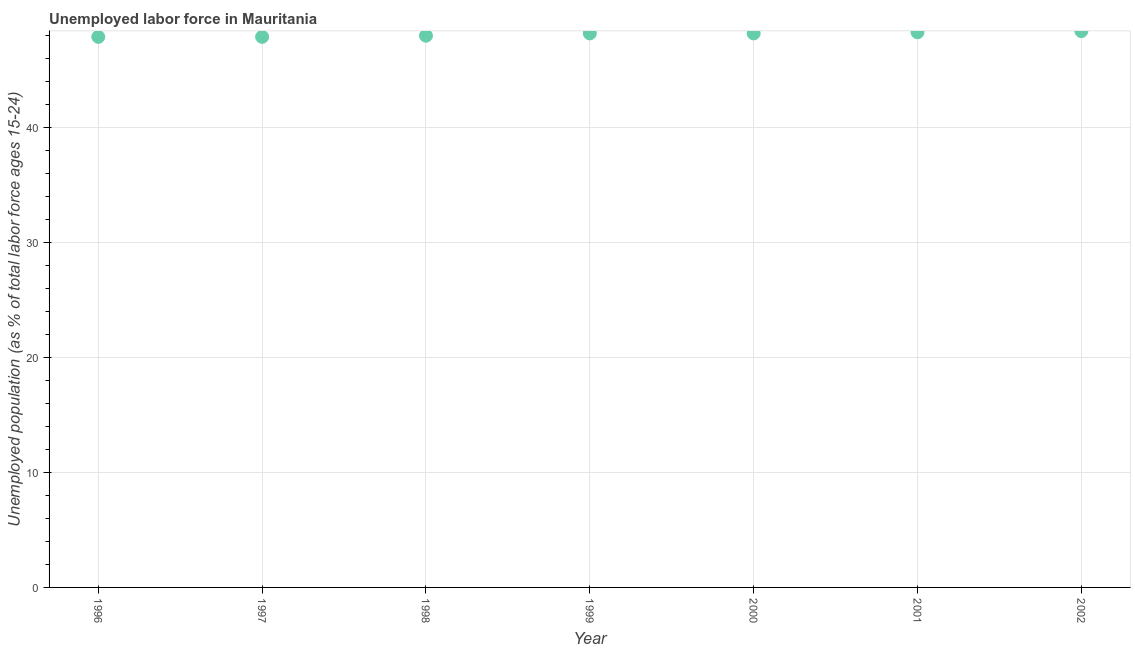Across all years, what is the maximum total unemployed youth population?
Provide a succinct answer. 48.4. Across all years, what is the minimum total unemployed youth population?
Provide a short and direct response. 47.9. What is the sum of the total unemployed youth population?
Offer a very short reply. 336.9. What is the difference between the total unemployed youth population in 1997 and 2002?
Your response must be concise. -0.5. What is the average total unemployed youth population per year?
Give a very brief answer. 48.13. What is the median total unemployed youth population?
Give a very brief answer. 48.2. What is the ratio of the total unemployed youth population in 2000 to that in 2002?
Keep it short and to the point. 1. Is the total unemployed youth population in 1996 less than that in 1997?
Offer a terse response. No. Is the difference between the total unemployed youth population in 1996 and 1998 greater than the difference between any two years?
Offer a very short reply. No. What is the difference between the highest and the second highest total unemployed youth population?
Ensure brevity in your answer.  0.1. Does the total unemployed youth population monotonically increase over the years?
Give a very brief answer. No. Are the values on the major ticks of Y-axis written in scientific E-notation?
Your answer should be compact. No. Does the graph contain any zero values?
Give a very brief answer. No. What is the title of the graph?
Your answer should be compact. Unemployed labor force in Mauritania. What is the label or title of the Y-axis?
Keep it short and to the point. Unemployed population (as % of total labor force ages 15-24). What is the Unemployed population (as % of total labor force ages 15-24) in 1996?
Provide a short and direct response. 47.9. What is the Unemployed population (as % of total labor force ages 15-24) in 1997?
Ensure brevity in your answer.  47.9. What is the Unemployed population (as % of total labor force ages 15-24) in 1999?
Offer a terse response. 48.2. What is the Unemployed population (as % of total labor force ages 15-24) in 2000?
Your response must be concise. 48.2. What is the Unemployed population (as % of total labor force ages 15-24) in 2001?
Your answer should be compact. 48.3. What is the Unemployed population (as % of total labor force ages 15-24) in 2002?
Give a very brief answer. 48.4. What is the difference between the Unemployed population (as % of total labor force ages 15-24) in 1996 and 1997?
Give a very brief answer. 0. What is the difference between the Unemployed population (as % of total labor force ages 15-24) in 1996 and 2000?
Provide a short and direct response. -0.3. What is the difference between the Unemployed population (as % of total labor force ages 15-24) in 1996 and 2002?
Your answer should be very brief. -0.5. What is the difference between the Unemployed population (as % of total labor force ages 15-24) in 1997 and 1999?
Keep it short and to the point. -0.3. What is the difference between the Unemployed population (as % of total labor force ages 15-24) in 1997 and 2001?
Your answer should be compact. -0.4. What is the difference between the Unemployed population (as % of total labor force ages 15-24) in 1997 and 2002?
Give a very brief answer. -0.5. What is the difference between the Unemployed population (as % of total labor force ages 15-24) in 1998 and 1999?
Your answer should be compact. -0.2. What is the difference between the Unemployed population (as % of total labor force ages 15-24) in 1998 and 2001?
Your answer should be very brief. -0.3. What is the difference between the Unemployed population (as % of total labor force ages 15-24) in 1999 and 2000?
Your answer should be compact. 0. What is the difference between the Unemployed population (as % of total labor force ages 15-24) in 1999 and 2002?
Offer a terse response. -0.2. What is the difference between the Unemployed population (as % of total labor force ages 15-24) in 2000 and 2001?
Your answer should be compact. -0.1. What is the difference between the Unemployed population (as % of total labor force ages 15-24) in 2000 and 2002?
Offer a terse response. -0.2. What is the difference between the Unemployed population (as % of total labor force ages 15-24) in 2001 and 2002?
Keep it short and to the point. -0.1. What is the ratio of the Unemployed population (as % of total labor force ages 15-24) in 1996 to that in 1998?
Offer a terse response. 1. What is the ratio of the Unemployed population (as % of total labor force ages 15-24) in 1996 to that in 2002?
Your response must be concise. 0.99. What is the ratio of the Unemployed population (as % of total labor force ages 15-24) in 1997 to that in 1998?
Make the answer very short. 1. What is the ratio of the Unemployed population (as % of total labor force ages 15-24) in 1997 to that in 1999?
Your answer should be compact. 0.99. What is the ratio of the Unemployed population (as % of total labor force ages 15-24) in 1997 to that in 2000?
Offer a terse response. 0.99. What is the ratio of the Unemployed population (as % of total labor force ages 15-24) in 1997 to that in 2001?
Ensure brevity in your answer.  0.99. What is the ratio of the Unemployed population (as % of total labor force ages 15-24) in 1997 to that in 2002?
Provide a succinct answer. 0.99. What is the ratio of the Unemployed population (as % of total labor force ages 15-24) in 1998 to that in 1999?
Give a very brief answer. 1. What is the ratio of the Unemployed population (as % of total labor force ages 15-24) in 1998 to that in 2000?
Provide a succinct answer. 1. What is the ratio of the Unemployed population (as % of total labor force ages 15-24) in 1998 to that in 2001?
Offer a very short reply. 0.99. What is the ratio of the Unemployed population (as % of total labor force ages 15-24) in 1998 to that in 2002?
Your response must be concise. 0.99. What is the ratio of the Unemployed population (as % of total labor force ages 15-24) in 1999 to that in 2000?
Ensure brevity in your answer.  1. What is the ratio of the Unemployed population (as % of total labor force ages 15-24) in 1999 to that in 2001?
Give a very brief answer. 1. What is the ratio of the Unemployed population (as % of total labor force ages 15-24) in 2000 to that in 2002?
Keep it short and to the point. 1. 